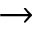<formula> <loc_0><loc_0><loc_500><loc_500>\to</formula> 